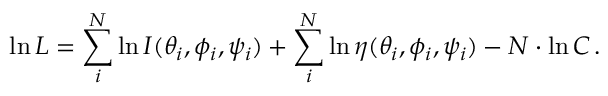<formula> <loc_0><loc_0><loc_500><loc_500>\ln { L } = \sum _ { i } ^ { N } \ln { I ( \theta _ { i } , \phi _ { i } , \psi _ { i } ) } + \sum _ { i } ^ { N } \ln { \eta ( \theta _ { i } , \phi _ { i } , \psi _ { i } ) } - N \cdot \ln { C } \, .</formula> 